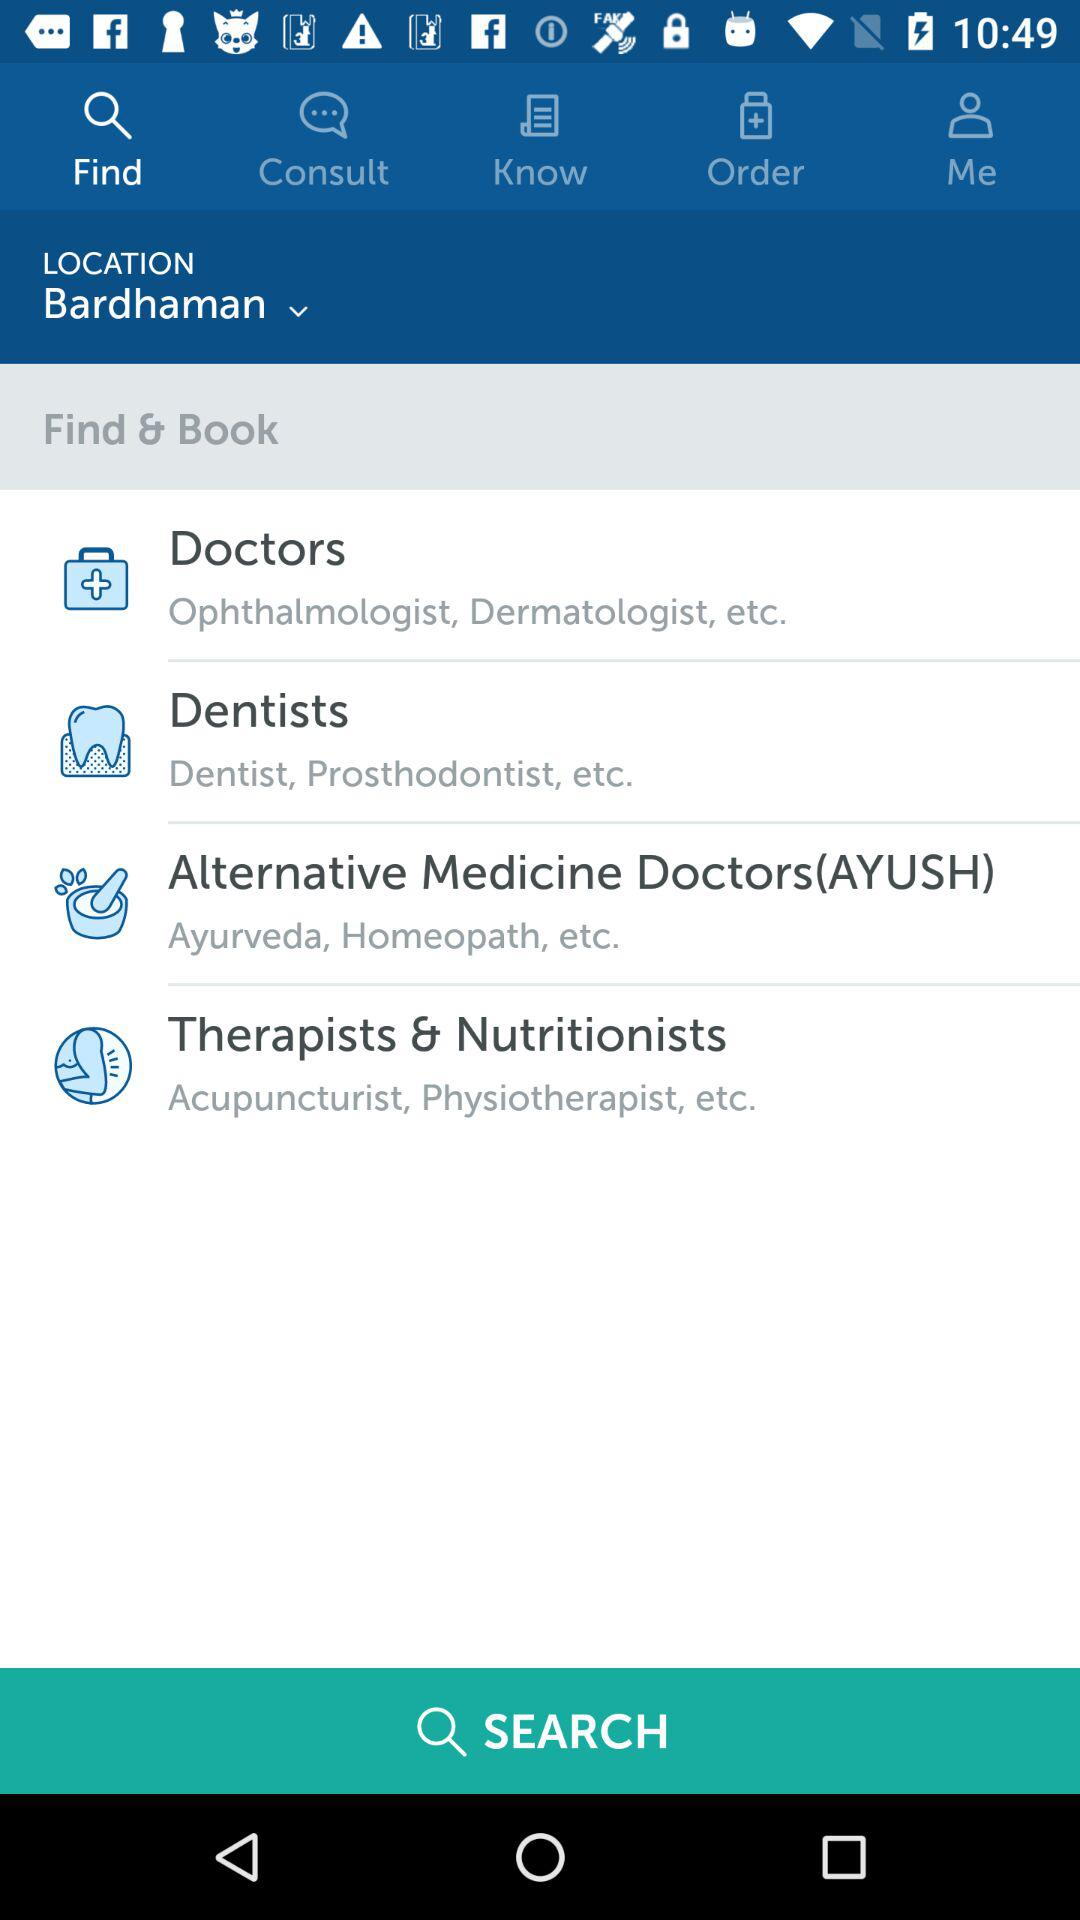How many categories are there for medical services?
Answer the question using a single word or phrase. 4 